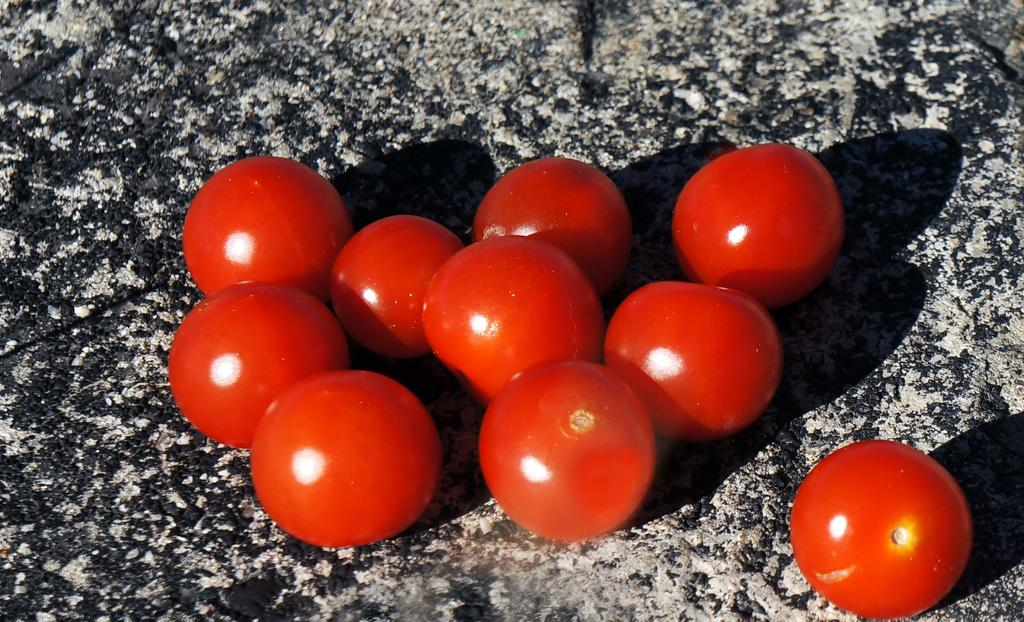What type of fruit is present in the image? There are tomatoes in the image. What color are the tomatoes? The tomatoes are red in color. What song is being sung by the tomatoes in the image? There are no tomatoes singing in the image, as tomatoes are not capable of singing. 